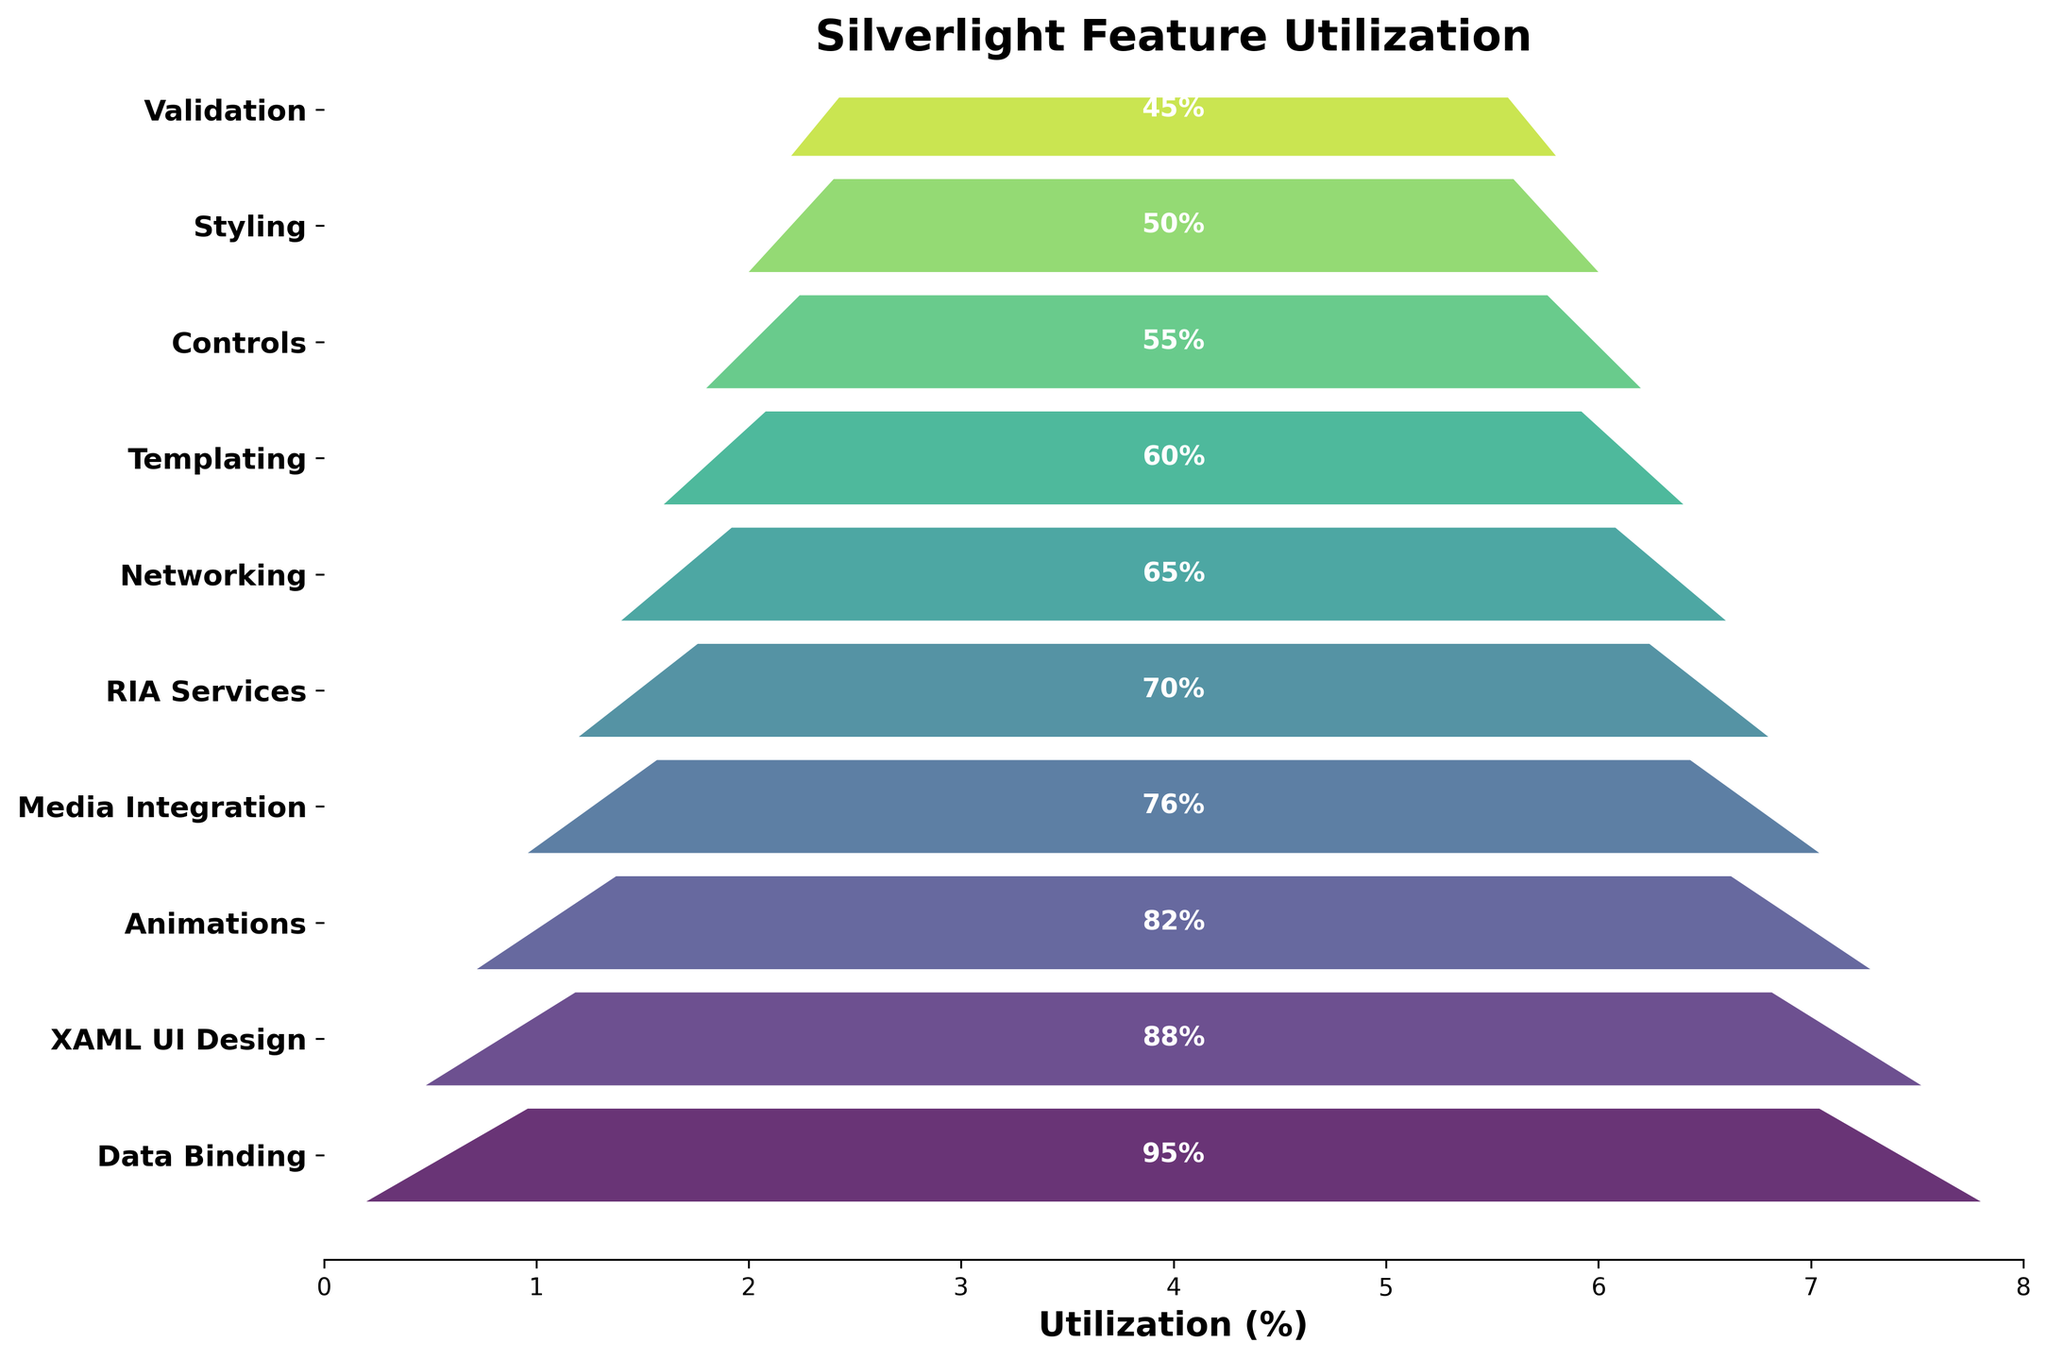What is the title of the chart? The title of the chart is displayed at the top and reads 'Silverlight Feature Utilization'.
Answer: Silverlight Feature Utilization Which feature has the highest utilization? The feature with the highest utilization is at the top of the funnel and is labeled with the highest utilization percentage.
Answer: Data Binding How many features are listed in the funnel chart? Count the number of unique segments in the funnel chart.
Answer: 10 What is the utilization percentage for Animations? Find the segment labeled 'Animations' and read the percentage displayed within it.
Answer: 82% Which feature has the lowest utilization, and what is its percentage? The feature at the bottom of the funnel chart is the one with the lowest utilization. Identify it and read the associated percentage.
Answer: Validation, 45% What is the total percentage of utilization if you combine Networking and Templating? Find the utilization percentages for Networking and Templating, then add them together (65% + 60%).
Answer: 125% Which feature has a higher utilization - Media Integration or Controls? Compare the utilization percentages of Media Integration and Controls.
Answer: Media Integration What is the average utilization percentage of the features listed in the chart? Add all the utilization percentages together and divide by the number of features ( (95+88+82+76+70+65+60+55+50+45) / 10 ).
Answer: 68.6% What feature directly follows RIA Services in the funnel chart? Identify the position of RIA Services in the funnel chart and see which feature is immediately below it.
Answer: Networking By how much does the utilization of Data Binding exceed that of Styling? Subtract the utilization percentage of Styling from that of Data Binding (95% - 50%).
Answer: 45% 